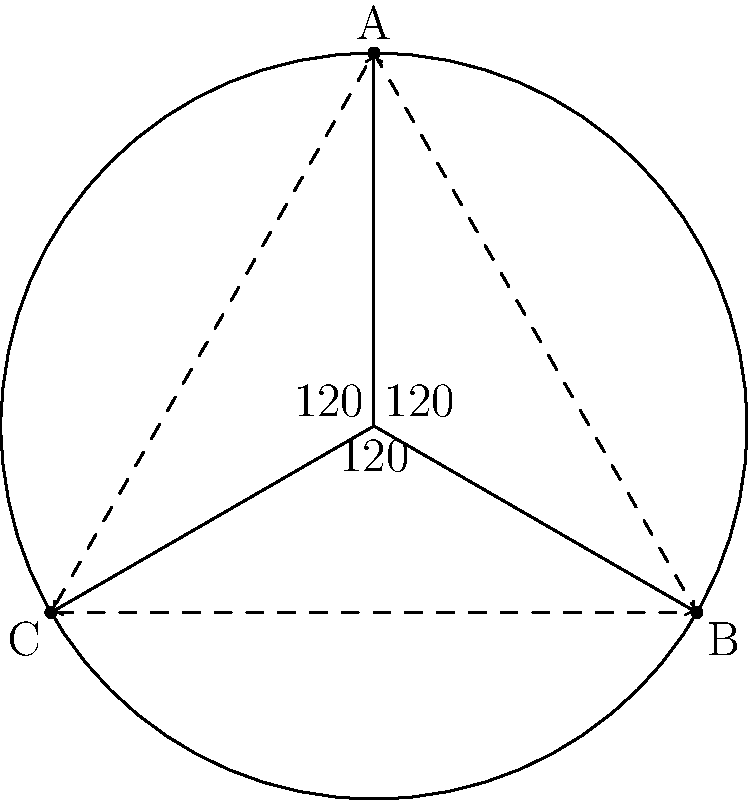In a roller derby match, a jammer needs to navigate through three opposing blockers positioned at points A, B, and C on a circular track. The blockers form an equilateral triangle, and the center of the track is at point O. If the jammer starts at point A and needs to pass through either B or C to score, which path should they take to minimize the distance traveled? Calculate the difference in distance between the two possible paths. Let's approach this step-by-step:

1) First, we need to recognize that the triangle ABC is equilateral, inscribed in a circle. This means that the central angles AOB, BOC, and COA are all 120°.

2) The jammer has two possible paths: A→B→C or A→C→B.

3) To calculate the length of these paths, we need to find the length of the arc between any two points. We can do this using the formula for arc length: $s = r\theta$, where $r$ is the radius and $\theta$ is the central angle in radians.

4) The central angle is 120° or $\frac{2\pi}{3}$ radians.

5) Let's assume the radius of the track is 1 unit for simplicity. Then the length of each arc is:

   $s = 1 \cdot \frac{2\pi}{3} = \frac{2\pi}{3}$

6) Path A→B→C: 
   Length = $\frac{2\pi}{3} + \frac{2\pi}{3} = \frac{4\pi}{3}$

7) Path A→C→B: 
   Length = $\frac{2\pi}{3} + \frac{4\pi}{3} = 2\pi$

8) The difference in distance is:
   $2\pi - \frac{4\pi}{3} = \frac{2\pi}{3}$

Therefore, the path A→B→C is shorter by $\frac{2\pi}{3}$ units.
Answer: A→B→C; $\frac{2\pi}{3}$ units shorter 